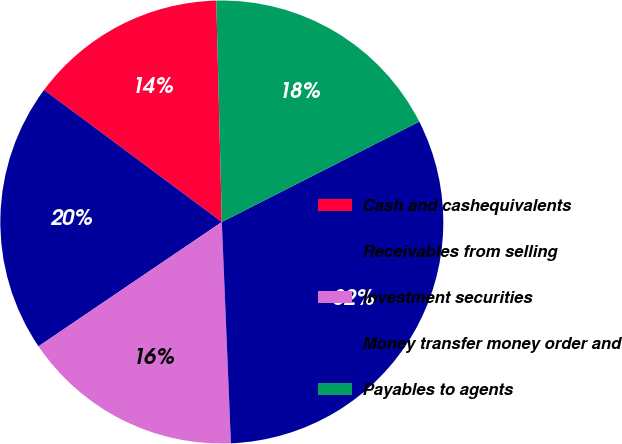Convert chart. <chart><loc_0><loc_0><loc_500><loc_500><pie_chart><fcel>Cash and cashequivalents<fcel>Receivables from selling<fcel>Investment securities<fcel>Money transfer money order and<fcel>Payables to agents<nl><fcel>14.43%<fcel>19.65%<fcel>16.17%<fcel>31.83%<fcel>17.91%<nl></chart> 